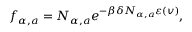Convert formula to latex. <formula><loc_0><loc_0><loc_500><loc_500>f _ { \alpha , a } = N _ { \alpha , a } e ^ { - \beta \delta N _ { \alpha , a } \varepsilon ( \ v { v } ) } ,</formula> 